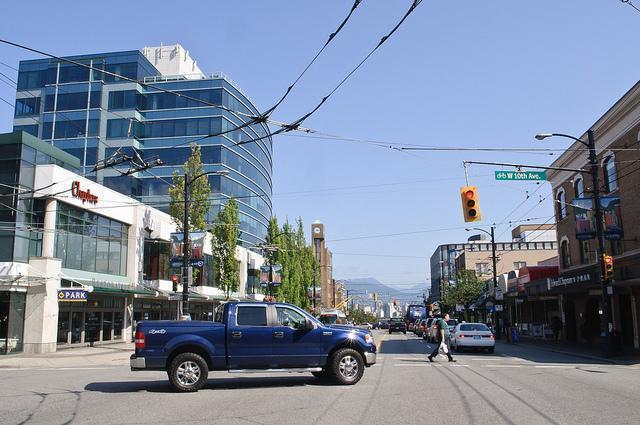What is the make of the blue pickup truck?
Pick the right solution, then justify: 'Answer: answer
Rationale: rationale.'
Options: Chevrolet, ford, toyota, gmc. Answer: ford.
Rationale: This is a 4x4 and it has the name of it on the side of it. 